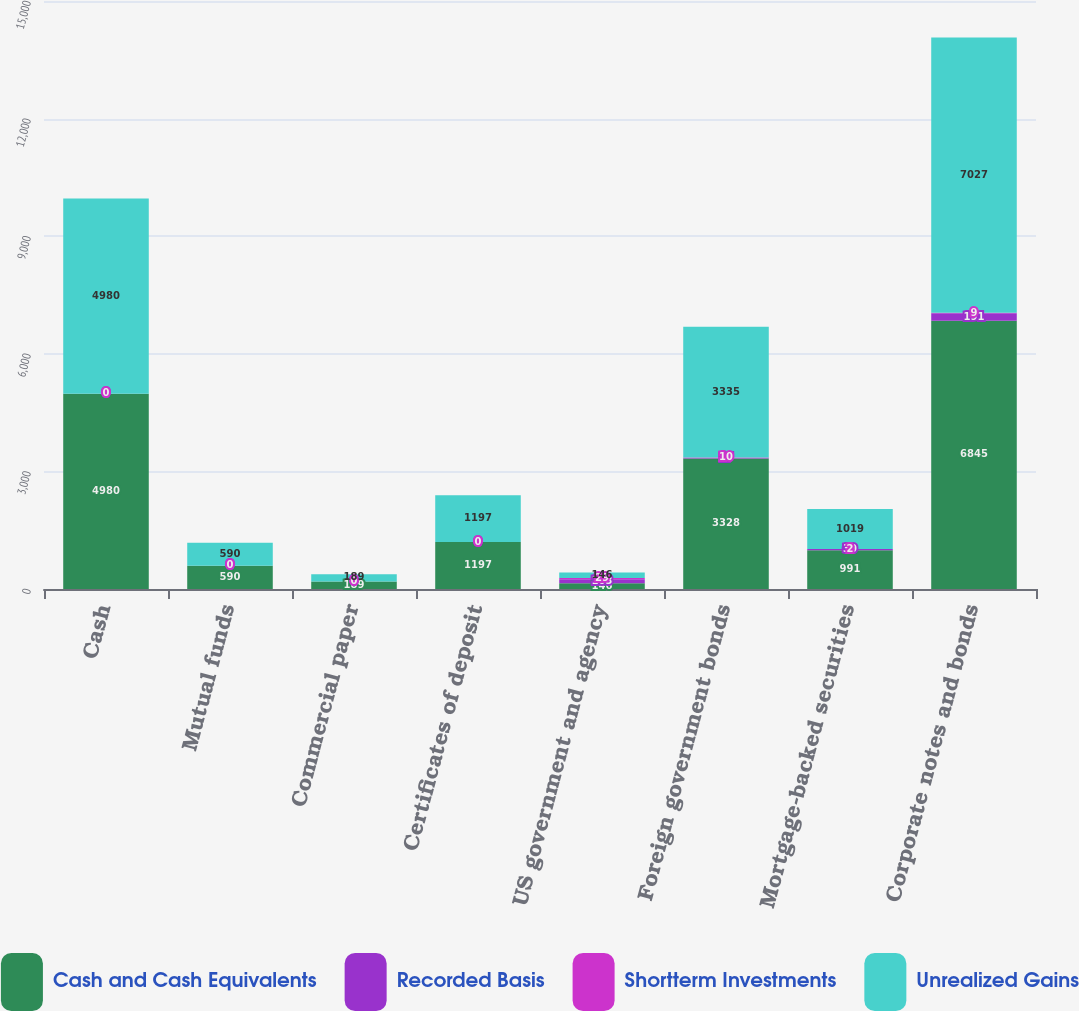<chart> <loc_0><loc_0><loc_500><loc_500><stacked_bar_chart><ecel><fcel>Cash<fcel>Mutual funds<fcel>Commercial paper<fcel>Certificates of deposit<fcel>US government and agency<fcel>Foreign government bonds<fcel>Mortgage-backed securities<fcel>Corporate notes and bonds<nl><fcel>Cash and Cash Equivalents<fcel>4980<fcel>590<fcel>189<fcel>1197<fcel>146<fcel>3328<fcel>991<fcel>6845<nl><fcel>Recorded Basis<fcel>0<fcel>0<fcel>0<fcel>0<fcel>103<fcel>17<fcel>30<fcel>191<nl><fcel>Shortterm Investments<fcel>0<fcel>0<fcel>0<fcel>0<fcel>29<fcel>10<fcel>2<fcel>9<nl><fcel>Unrealized Gains<fcel>4980<fcel>590<fcel>189<fcel>1197<fcel>146<fcel>3335<fcel>1019<fcel>7027<nl></chart> 